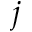<formula> <loc_0><loc_0><loc_500><loc_500>j</formula> 